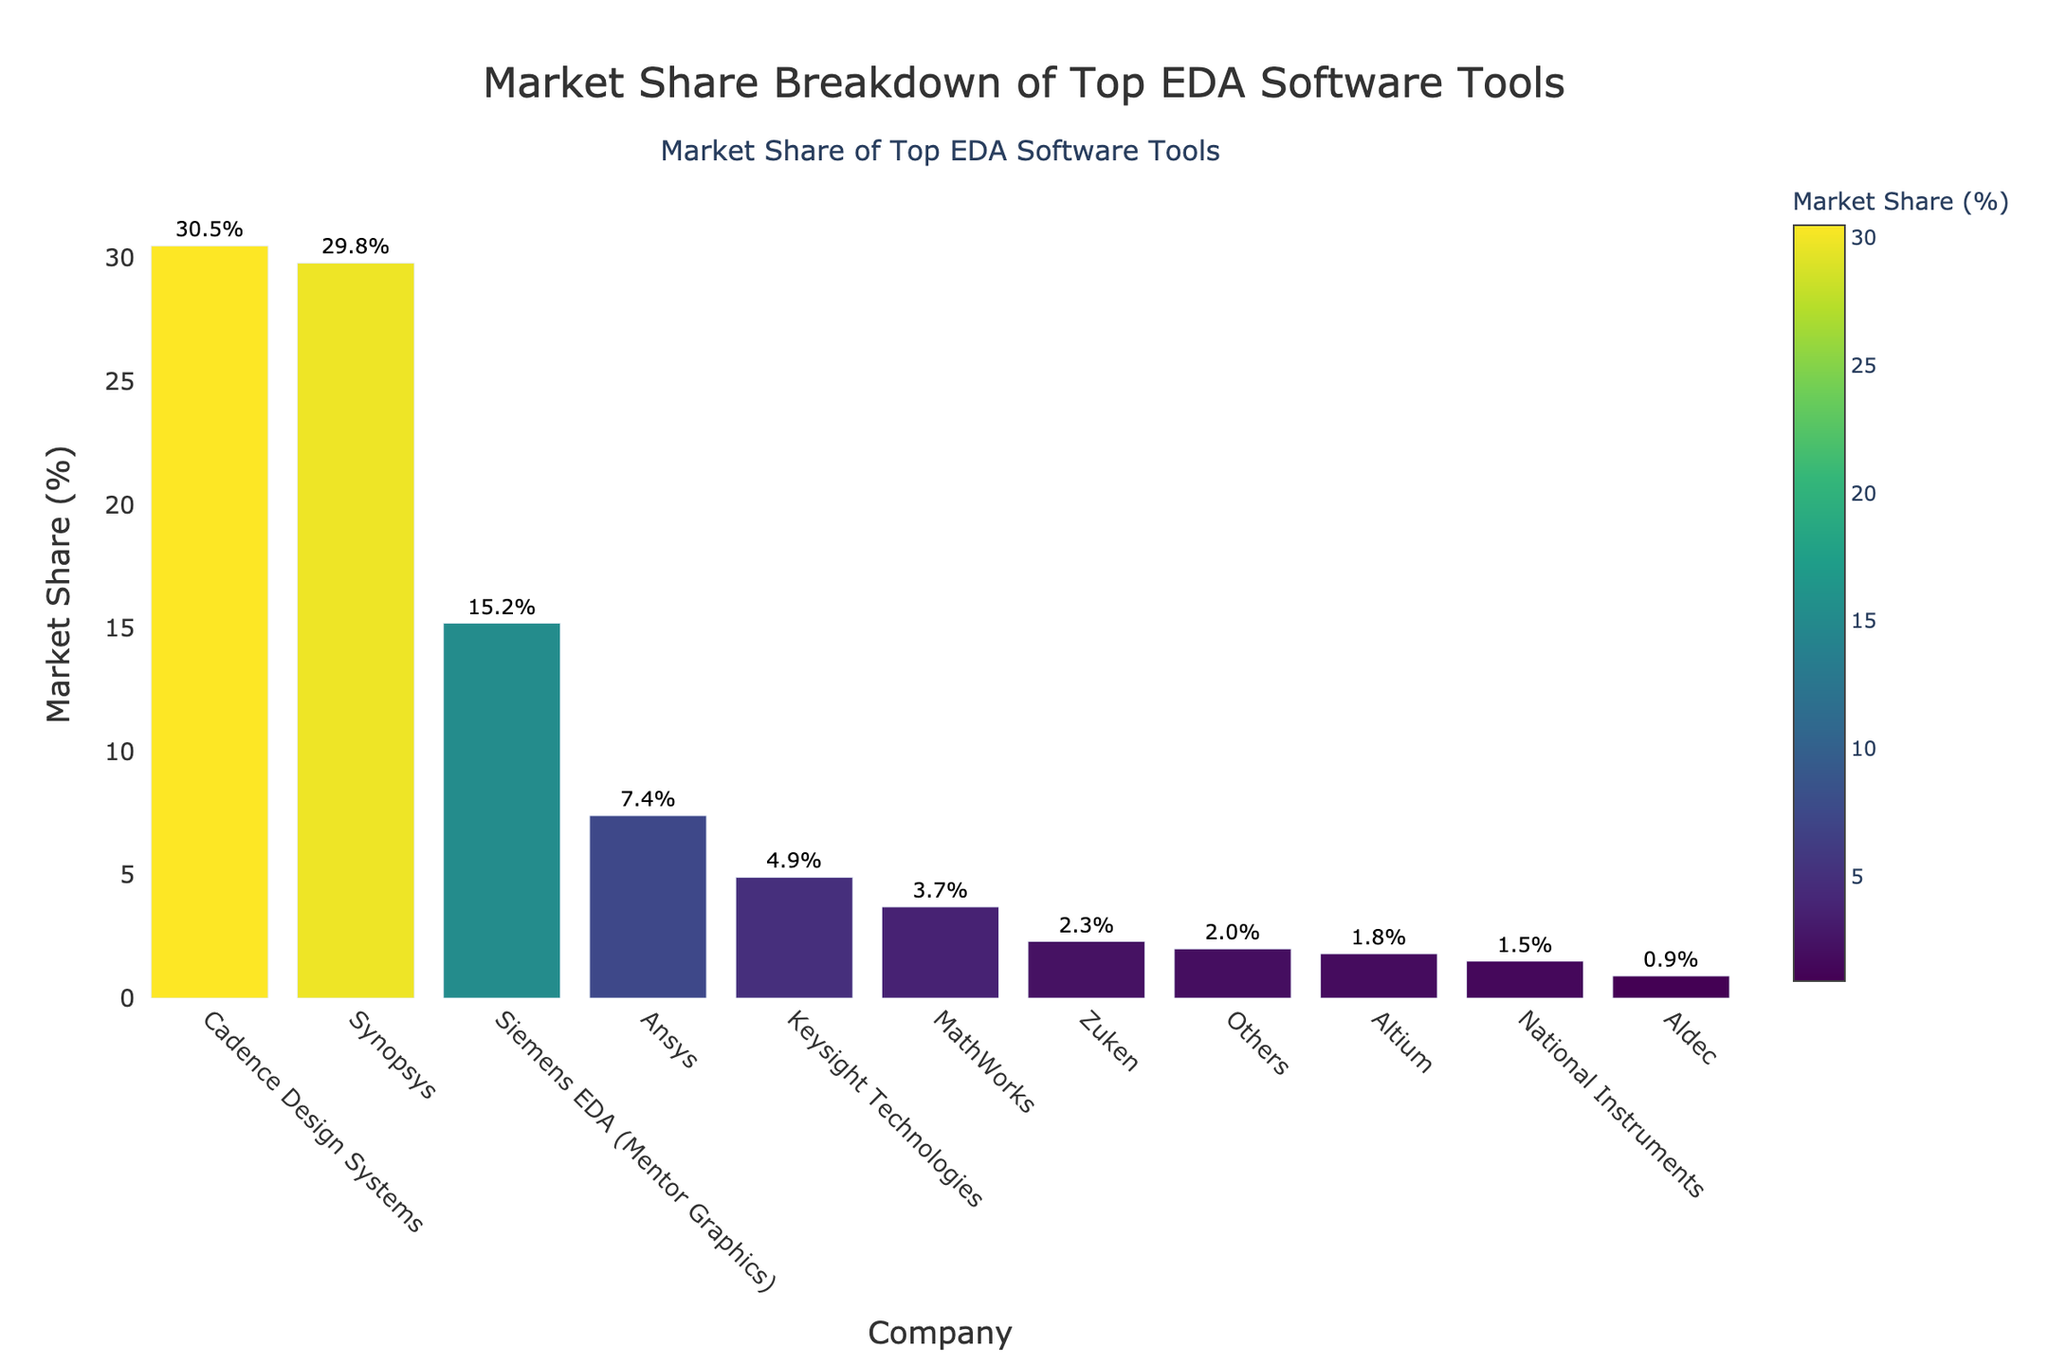What is the market share of the company with the highest market share? The company with the highest market share can be identified by looking at the tallest bar in the chart. The tallest bar represents Cadence Design Systems with a market share of 30.5%.
Answer: 30.5% Which company has a slightly less market share than Cadence Design Systems? The bar right next to the tallest one represents the second-highest market share, which is Synopsys with 29.8%.
Answer: Synopsys What is the combined market share of Siemens EDA (Mentor Graphics) and Ansys? Siemens EDA (Mentor Graphics) has a market share of 15.2% and Ansys has a market share of 7.4%. Adding these together gives 15.2 + 7.4 = 22.6%.
Answer: 22.6% How many companies have a market share below 5%? By visually inspecting the length of each bar, the companies with market shares below 5% are Keysight Technologies, MathWorks, Zuken, Altium, National Instruments, and Aldec. Counting these gives 6 companies.
Answer: 6 Which company has the smallest market share listed, and what is it? The shortest bar represents Aldec with a market share of 0.9%.
Answer: Aldec, 0.9% What is the difference in market share between Synopsys and Ansys? Synopsys has a market share of 29.8% and Ansys has a market share of 7.4%. The difference is 29.8 - 7.4 = 22.4%.
Answer: 22.4% Which color indicates the highest market share in the bar chart, and which company does it represent? The darkest color in the Viridis colorscale indicates the highest market share. This color represents Cadence Design Systems with 30.5%.
Answer: The darkest color, Cadence Design Systems How does the market share of MathWorks compare to that of Zuken? MathWorks has a market share of 3.7% while Zuken has a market share of 2.3%. MathWorks has a higher market share than Zuken.
Answer: MathWorks > Zuken What is the average market share of the top three companies? The top three companies by market share are Cadence Design Systems (30.5%), Synopsys (29.8%), and Siemens EDA (Mentor Graphics) (15.2%). The average market share is (30.5 + 29.8 + 15.2) / 3 = 75.5 / 3 = 25.17%.
Answer: 25.17% What is the percentage difference in market share between the companies with the highest and second highest market shares? Cadence Design Systems has a market share of 30.5% and Synopsys has 29.8%. The percentage difference is calculated as ((30.5 - 29.8) / 29.8) * 100 = 0.7 / 29.8 * 100 ≈ 2.35%.
Answer: 2.35% 